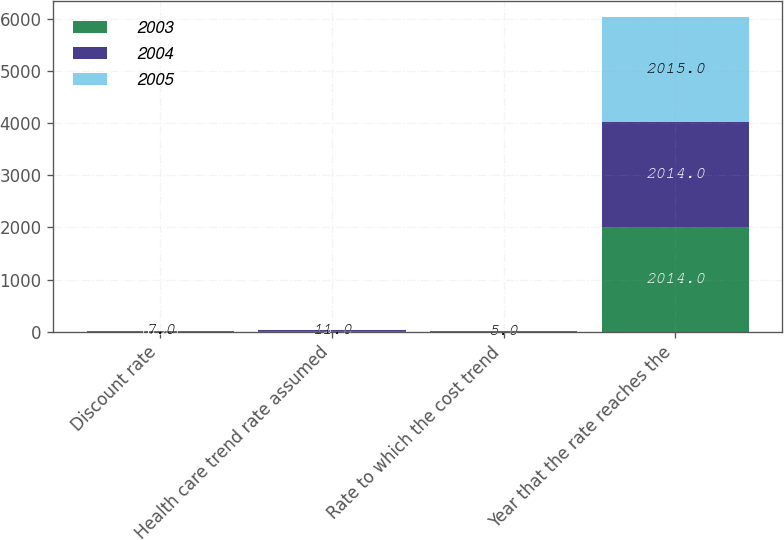<chart> <loc_0><loc_0><loc_500><loc_500><stacked_bar_chart><ecel><fcel>Discount rate<fcel>Health care trend rate assumed<fcel>Rate to which the cost trend<fcel>Year that the rate reaches the<nl><fcel>2003<fcel>6.25<fcel>12<fcel>5<fcel>2014<nl><fcel>2004<fcel>6<fcel>13<fcel>5<fcel>2014<nl><fcel>2005<fcel>7<fcel>11<fcel>5<fcel>2015<nl></chart> 